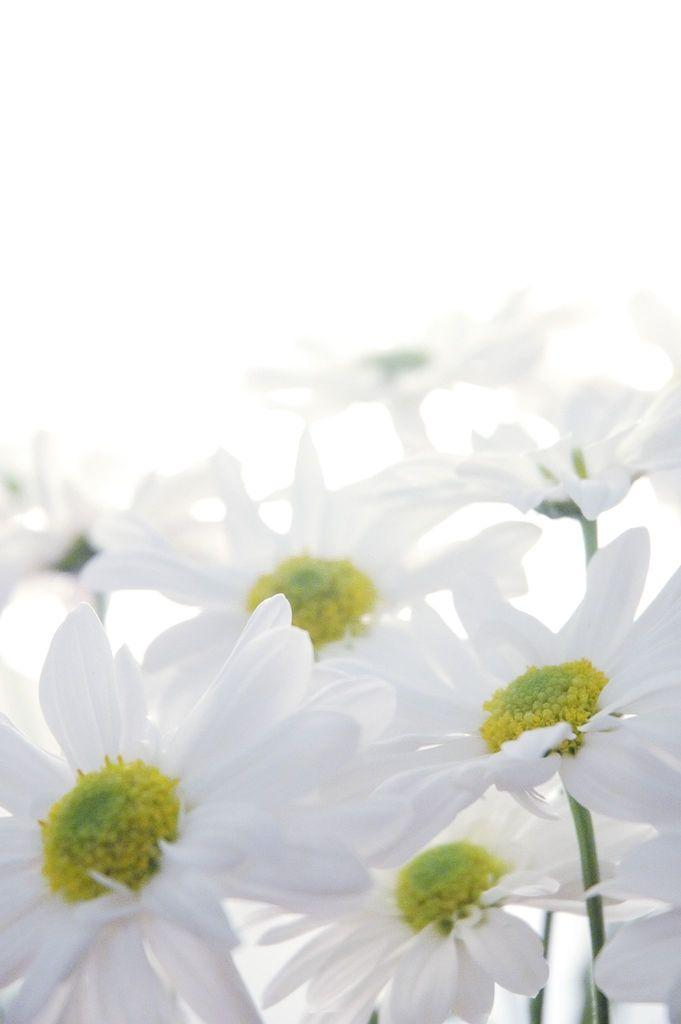What type of plants can be seen in the image? There are flowers in the image. How are the flowers connected to the rest of the plant? The flowers are attached to stems. What color is the backdrop of the image? The backdrop of the image is white. What is the design of the land visible in the image? There is no land visible in the image; it only features flowers with stems against a white backdrop. 